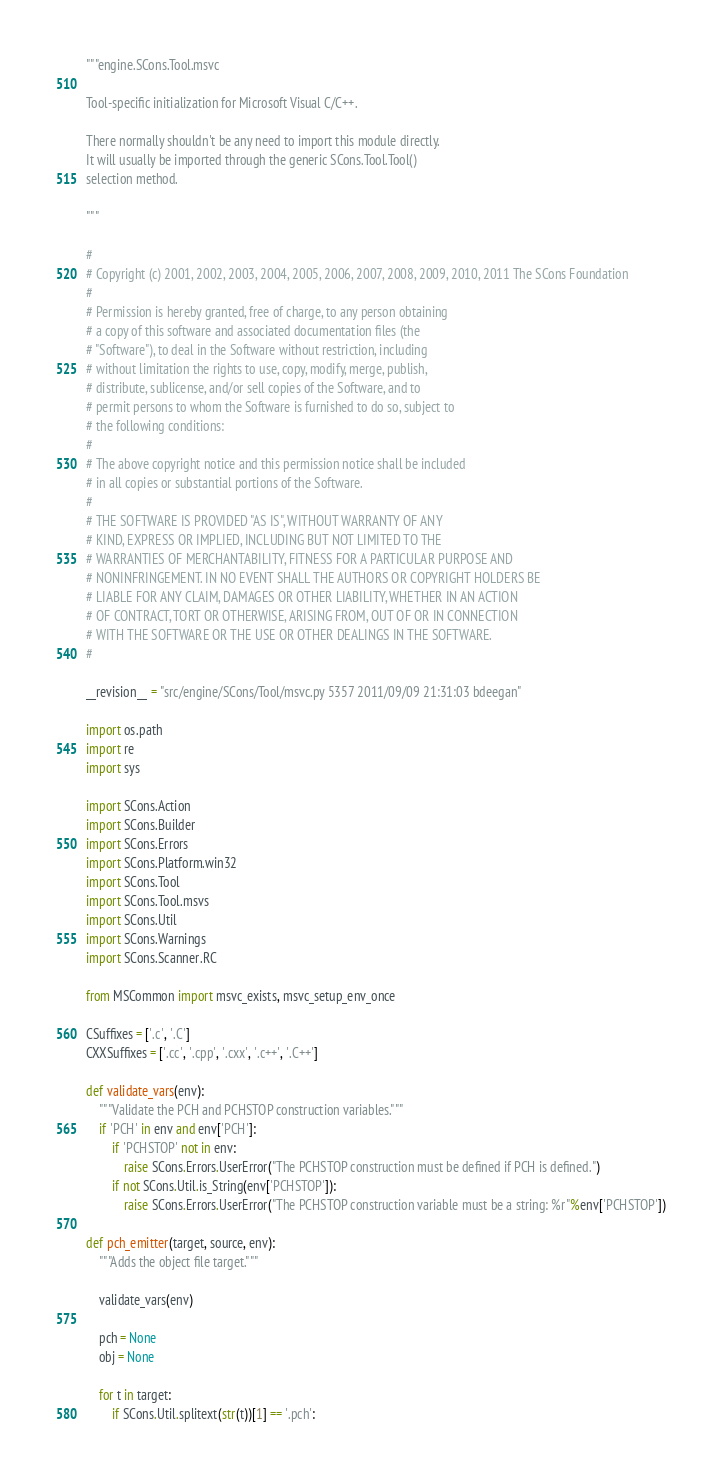Convert code to text. <code><loc_0><loc_0><loc_500><loc_500><_Python_>"""engine.SCons.Tool.msvc

Tool-specific initialization for Microsoft Visual C/C++.

There normally shouldn't be any need to import this module directly.
It will usually be imported through the generic SCons.Tool.Tool()
selection method.

"""

#
# Copyright (c) 2001, 2002, 2003, 2004, 2005, 2006, 2007, 2008, 2009, 2010, 2011 The SCons Foundation
#
# Permission is hereby granted, free of charge, to any person obtaining
# a copy of this software and associated documentation files (the
# "Software"), to deal in the Software without restriction, including
# without limitation the rights to use, copy, modify, merge, publish,
# distribute, sublicense, and/or sell copies of the Software, and to
# permit persons to whom the Software is furnished to do so, subject to
# the following conditions:
#
# The above copyright notice and this permission notice shall be included
# in all copies or substantial portions of the Software.
#
# THE SOFTWARE IS PROVIDED "AS IS", WITHOUT WARRANTY OF ANY
# KIND, EXPRESS OR IMPLIED, INCLUDING BUT NOT LIMITED TO THE
# WARRANTIES OF MERCHANTABILITY, FITNESS FOR A PARTICULAR PURPOSE AND
# NONINFRINGEMENT. IN NO EVENT SHALL THE AUTHORS OR COPYRIGHT HOLDERS BE
# LIABLE FOR ANY CLAIM, DAMAGES OR OTHER LIABILITY, WHETHER IN AN ACTION
# OF CONTRACT, TORT OR OTHERWISE, ARISING FROM, OUT OF OR IN CONNECTION
# WITH THE SOFTWARE OR THE USE OR OTHER DEALINGS IN THE SOFTWARE.
#

__revision__ = "src/engine/SCons/Tool/msvc.py 5357 2011/09/09 21:31:03 bdeegan"

import os.path
import re
import sys

import SCons.Action
import SCons.Builder
import SCons.Errors
import SCons.Platform.win32
import SCons.Tool
import SCons.Tool.msvs
import SCons.Util
import SCons.Warnings
import SCons.Scanner.RC

from MSCommon import msvc_exists, msvc_setup_env_once

CSuffixes = ['.c', '.C']
CXXSuffixes = ['.cc', '.cpp', '.cxx', '.c++', '.C++']

def validate_vars(env):
    """Validate the PCH and PCHSTOP construction variables."""
    if 'PCH' in env and env['PCH']:
        if 'PCHSTOP' not in env:
            raise SCons.Errors.UserError("The PCHSTOP construction must be defined if PCH is defined.")
        if not SCons.Util.is_String(env['PCHSTOP']):
            raise SCons.Errors.UserError("The PCHSTOP construction variable must be a string: %r"%env['PCHSTOP'])

def pch_emitter(target, source, env):
    """Adds the object file target."""

    validate_vars(env)

    pch = None
    obj = None

    for t in target:
        if SCons.Util.splitext(str(t))[1] == '.pch':</code> 